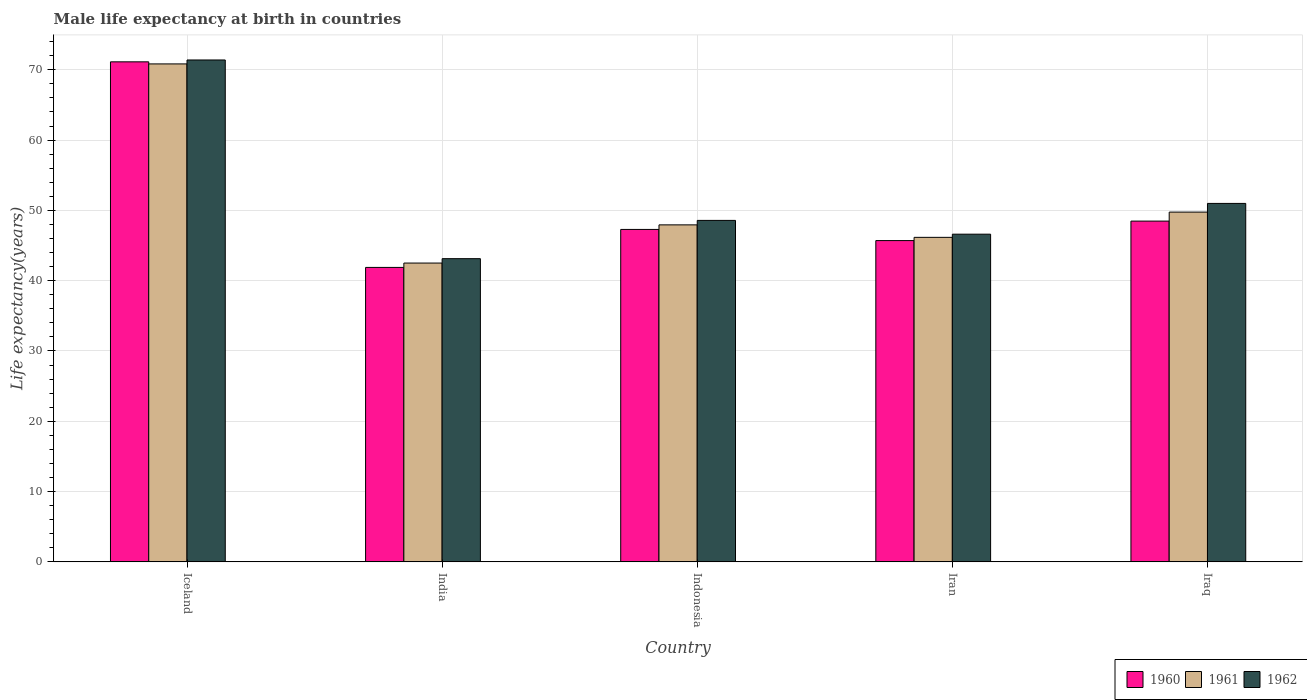How many different coloured bars are there?
Your answer should be very brief. 3. Are the number of bars on each tick of the X-axis equal?
Make the answer very short. Yes. How many bars are there on the 2nd tick from the left?
Offer a terse response. 3. What is the label of the 1st group of bars from the left?
Your answer should be very brief. Iceland. In how many cases, is the number of bars for a given country not equal to the number of legend labels?
Your response must be concise. 0. What is the male life expectancy at birth in 1962 in Iraq?
Make the answer very short. 50.99. Across all countries, what is the maximum male life expectancy at birth in 1962?
Make the answer very short. 71.4. Across all countries, what is the minimum male life expectancy at birth in 1962?
Your answer should be compact. 43.13. In which country was the male life expectancy at birth in 1962 minimum?
Keep it short and to the point. India. What is the total male life expectancy at birth in 1961 in the graph?
Keep it short and to the point. 257.22. What is the difference between the male life expectancy at birth in 1960 in India and that in Iran?
Provide a succinct answer. -3.82. What is the difference between the male life expectancy at birth in 1960 in Iceland and the male life expectancy at birth in 1962 in Iraq?
Provide a short and direct response. 20.14. What is the average male life expectancy at birth in 1960 per country?
Keep it short and to the point. 50.9. What is the difference between the male life expectancy at birth of/in 1962 and male life expectancy at birth of/in 1961 in Iceland?
Your answer should be compact. 0.56. What is the ratio of the male life expectancy at birth in 1961 in India to that in Iraq?
Your answer should be compact. 0.85. Is the difference between the male life expectancy at birth in 1962 in Iceland and India greater than the difference between the male life expectancy at birth in 1961 in Iceland and India?
Provide a short and direct response. No. What is the difference between the highest and the second highest male life expectancy at birth in 1962?
Make the answer very short. -2.41. What is the difference between the highest and the lowest male life expectancy at birth in 1961?
Your answer should be compact. 28.33. In how many countries, is the male life expectancy at birth in 1961 greater than the average male life expectancy at birth in 1961 taken over all countries?
Your response must be concise. 1. What does the 1st bar from the left in Iceland represents?
Keep it short and to the point. 1960. What does the 1st bar from the right in Iran represents?
Give a very brief answer. 1962. Is it the case that in every country, the sum of the male life expectancy at birth in 1962 and male life expectancy at birth in 1960 is greater than the male life expectancy at birth in 1961?
Your answer should be very brief. Yes. What is the difference between two consecutive major ticks on the Y-axis?
Your response must be concise. 10. Are the values on the major ticks of Y-axis written in scientific E-notation?
Your response must be concise. No. Does the graph contain grids?
Your answer should be compact. Yes. How many legend labels are there?
Offer a very short reply. 3. What is the title of the graph?
Keep it short and to the point. Male life expectancy at birth in countries. What is the label or title of the Y-axis?
Your answer should be compact. Life expectancy(years). What is the Life expectancy(years) in 1960 in Iceland?
Make the answer very short. 71.14. What is the Life expectancy(years) of 1961 in Iceland?
Give a very brief answer. 70.84. What is the Life expectancy(years) in 1962 in Iceland?
Provide a short and direct response. 71.4. What is the Life expectancy(years) in 1960 in India?
Ensure brevity in your answer.  41.89. What is the Life expectancy(years) in 1961 in India?
Provide a short and direct response. 42.51. What is the Life expectancy(years) in 1962 in India?
Make the answer very short. 43.13. What is the Life expectancy(years) of 1960 in Indonesia?
Your answer should be compact. 47.29. What is the Life expectancy(years) of 1961 in Indonesia?
Your response must be concise. 47.94. What is the Life expectancy(years) in 1962 in Indonesia?
Your answer should be compact. 48.58. What is the Life expectancy(years) in 1960 in Iran?
Keep it short and to the point. 45.71. What is the Life expectancy(years) in 1961 in Iran?
Your response must be concise. 46.17. What is the Life expectancy(years) of 1962 in Iran?
Your answer should be very brief. 46.62. What is the Life expectancy(years) in 1960 in Iraq?
Give a very brief answer. 48.48. What is the Life expectancy(years) of 1961 in Iraq?
Offer a terse response. 49.76. What is the Life expectancy(years) in 1962 in Iraq?
Offer a terse response. 50.99. Across all countries, what is the maximum Life expectancy(years) in 1960?
Ensure brevity in your answer.  71.14. Across all countries, what is the maximum Life expectancy(years) in 1961?
Make the answer very short. 70.84. Across all countries, what is the maximum Life expectancy(years) of 1962?
Offer a very short reply. 71.4. Across all countries, what is the minimum Life expectancy(years) in 1960?
Your answer should be compact. 41.89. Across all countries, what is the minimum Life expectancy(years) in 1961?
Your answer should be very brief. 42.51. Across all countries, what is the minimum Life expectancy(years) in 1962?
Ensure brevity in your answer.  43.13. What is the total Life expectancy(years) of 1960 in the graph?
Keep it short and to the point. 254.5. What is the total Life expectancy(years) in 1961 in the graph?
Provide a short and direct response. 257.22. What is the total Life expectancy(years) in 1962 in the graph?
Offer a very short reply. 260.72. What is the difference between the Life expectancy(years) of 1960 in Iceland and that in India?
Your answer should be compact. 29.25. What is the difference between the Life expectancy(years) in 1961 in Iceland and that in India?
Make the answer very short. 28.33. What is the difference between the Life expectancy(years) of 1962 in Iceland and that in India?
Provide a short and direct response. 28.27. What is the difference between the Life expectancy(years) of 1960 in Iceland and that in Indonesia?
Your response must be concise. 23.84. What is the difference between the Life expectancy(years) of 1961 in Iceland and that in Indonesia?
Provide a succinct answer. 22.9. What is the difference between the Life expectancy(years) of 1962 in Iceland and that in Indonesia?
Give a very brief answer. 22.82. What is the difference between the Life expectancy(years) of 1960 in Iceland and that in Iran?
Provide a short and direct response. 25.43. What is the difference between the Life expectancy(years) of 1961 in Iceland and that in Iran?
Your answer should be very brief. 24.67. What is the difference between the Life expectancy(years) in 1962 in Iceland and that in Iran?
Keep it short and to the point. 24.78. What is the difference between the Life expectancy(years) of 1960 in Iceland and that in Iraq?
Make the answer very short. 22.66. What is the difference between the Life expectancy(years) in 1961 in Iceland and that in Iraq?
Offer a terse response. 21.08. What is the difference between the Life expectancy(years) of 1962 in Iceland and that in Iraq?
Offer a terse response. 20.41. What is the difference between the Life expectancy(years) in 1960 in India and that in Indonesia?
Ensure brevity in your answer.  -5.4. What is the difference between the Life expectancy(years) in 1961 in India and that in Indonesia?
Keep it short and to the point. -5.43. What is the difference between the Life expectancy(years) of 1962 in India and that in Indonesia?
Provide a short and direct response. -5.44. What is the difference between the Life expectancy(years) of 1960 in India and that in Iran?
Provide a succinct answer. -3.82. What is the difference between the Life expectancy(years) in 1961 in India and that in Iran?
Your answer should be compact. -3.66. What is the difference between the Life expectancy(years) of 1962 in India and that in Iran?
Offer a very short reply. -3.48. What is the difference between the Life expectancy(years) in 1960 in India and that in Iraq?
Give a very brief answer. -6.59. What is the difference between the Life expectancy(years) of 1961 in India and that in Iraq?
Provide a short and direct response. -7.25. What is the difference between the Life expectancy(years) in 1962 in India and that in Iraq?
Make the answer very short. -7.86. What is the difference between the Life expectancy(years) of 1960 in Indonesia and that in Iran?
Offer a terse response. 1.59. What is the difference between the Life expectancy(years) in 1961 in Indonesia and that in Iran?
Your answer should be very brief. 1.77. What is the difference between the Life expectancy(years) of 1962 in Indonesia and that in Iran?
Keep it short and to the point. 1.96. What is the difference between the Life expectancy(years) in 1960 in Indonesia and that in Iraq?
Your answer should be very brief. -1.19. What is the difference between the Life expectancy(years) in 1961 in Indonesia and that in Iraq?
Your answer should be compact. -1.81. What is the difference between the Life expectancy(years) in 1962 in Indonesia and that in Iraq?
Your response must be concise. -2.42. What is the difference between the Life expectancy(years) in 1960 in Iran and that in Iraq?
Your response must be concise. -2.77. What is the difference between the Life expectancy(years) in 1961 in Iran and that in Iraq?
Your answer should be compact. -3.59. What is the difference between the Life expectancy(years) in 1962 in Iran and that in Iraq?
Your answer should be very brief. -4.38. What is the difference between the Life expectancy(years) of 1960 in Iceland and the Life expectancy(years) of 1961 in India?
Offer a terse response. 28.62. What is the difference between the Life expectancy(years) in 1960 in Iceland and the Life expectancy(years) in 1962 in India?
Ensure brevity in your answer.  28. What is the difference between the Life expectancy(years) in 1961 in Iceland and the Life expectancy(years) in 1962 in India?
Your response must be concise. 27.71. What is the difference between the Life expectancy(years) of 1960 in Iceland and the Life expectancy(years) of 1961 in Indonesia?
Your response must be concise. 23.19. What is the difference between the Life expectancy(years) in 1960 in Iceland and the Life expectancy(years) in 1962 in Indonesia?
Your answer should be compact. 22.56. What is the difference between the Life expectancy(years) of 1961 in Iceland and the Life expectancy(years) of 1962 in Indonesia?
Offer a terse response. 22.26. What is the difference between the Life expectancy(years) in 1960 in Iceland and the Life expectancy(years) in 1961 in Iran?
Give a very brief answer. 24.97. What is the difference between the Life expectancy(years) of 1960 in Iceland and the Life expectancy(years) of 1962 in Iran?
Give a very brief answer. 24.52. What is the difference between the Life expectancy(years) in 1961 in Iceland and the Life expectancy(years) in 1962 in Iran?
Ensure brevity in your answer.  24.22. What is the difference between the Life expectancy(years) of 1960 in Iceland and the Life expectancy(years) of 1961 in Iraq?
Offer a terse response. 21.38. What is the difference between the Life expectancy(years) in 1960 in Iceland and the Life expectancy(years) in 1962 in Iraq?
Provide a succinct answer. 20.14. What is the difference between the Life expectancy(years) in 1961 in Iceland and the Life expectancy(years) in 1962 in Iraq?
Offer a very short reply. 19.85. What is the difference between the Life expectancy(years) of 1960 in India and the Life expectancy(years) of 1961 in Indonesia?
Provide a short and direct response. -6.05. What is the difference between the Life expectancy(years) in 1960 in India and the Life expectancy(years) in 1962 in Indonesia?
Provide a short and direct response. -6.69. What is the difference between the Life expectancy(years) in 1961 in India and the Life expectancy(years) in 1962 in Indonesia?
Offer a terse response. -6.07. What is the difference between the Life expectancy(years) of 1960 in India and the Life expectancy(years) of 1961 in Iran?
Give a very brief answer. -4.28. What is the difference between the Life expectancy(years) of 1960 in India and the Life expectancy(years) of 1962 in Iran?
Ensure brevity in your answer.  -4.73. What is the difference between the Life expectancy(years) in 1961 in India and the Life expectancy(years) in 1962 in Iran?
Your answer should be very brief. -4.11. What is the difference between the Life expectancy(years) of 1960 in India and the Life expectancy(years) of 1961 in Iraq?
Provide a succinct answer. -7.87. What is the difference between the Life expectancy(years) in 1960 in India and the Life expectancy(years) in 1962 in Iraq?
Provide a succinct answer. -9.1. What is the difference between the Life expectancy(years) in 1961 in India and the Life expectancy(years) in 1962 in Iraq?
Provide a short and direct response. -8.48. What is the difference between the Life expectancy(years) of 1960 in Indonesia and the Life expectancy(years) of 1961 in Iran?
Offer a very short reply. 1.13. What is the difference between the Life expectancy(years) in 1960 in Indonesia and the Life expectancy(years) in 1962 in Iran?
Provide a short and direct response. 0.68. What is the difference between the Life expectancy(years) of 1961 in Indonesia and the Life expectancy(years) of 1962 in Iran?
Offer a very short reply. 1.32. What is the difference between the Life expectancy(years) in 1960 in Indonesia and the Life expectancy(years) in 1961 in Iraq?
Your answer should be very brief. -2.46. What is the difference between the Life expectancy(years) in 1960 in Indonesia and the Life expectancy(years) in 1962 in Iraq?
Provide a short and direct response. -3.7. What is the difference between the Life expectancy(years) in 1961 in Indonesia and the Life expectancy(years) in 1962 in Iraq?
Ensure brevity in your answer.  -3.05. What is the difference between the Life expectancy(years) of 1960 in Iran and the Life expectancy(years) of 1961 in Iraq?
Offer a terse response. -4.05. What is the difference between the Life expectancy(years) in 1960 in Iran and the Life expectancy(years) in 1962 in Iraq?
Give a very brief answer. -5.29. What is the difference between the Life expectancy(years) of 1961 in Iran and the Life expectancy(years) of 1962 in Iraq?
Offer a terse response. -4.83. What is the average Life expectancy(years) of 1960 per country?
Offer a terse response. 50.9. What is the average Life expectancy(years) in 1961 per country?
Your answer should be compact. 51.44. What is the average Life expectancy(years) of 1962 per country?
Your answer should be very brief. 52.14. What is the difference between the Life expectancy(years) of 1960 and Life expectancy(years) of 1961 in Iceland?
Make the answer very short. 0.29. What is the difference between the Life expectancy(years) of 1960 and Life expectancy(years) of 1962 in Iceland?
Your answer should be very brief. -0.27. What is the difference between the Life expectancy(years) of 1961 and Life expectancy(years) of 1962 in Iceland?
Your answer should be very brief. -0.56. What is the difference between the Life expectancy(years) in 1960 and Life expectancy(years) in 1961 in India?
Offer a very short reply. -0.62. What is the difference between the Life expectancy(years) in 1960 and Life expectancy(years) in 1962 in India?
Offer a very short reply. -1.24. What is the difference between the Life expectancy(years) in 1961 and Life expectancy(years) in 1962 in India?
Ensure brevity in your answer.  -0.62. What is the difference between the Life expectancy(years) in 1960 and Life expectancy(years) in 1961 in Indonesia?
Offer a terse response. -0.65. What is the difference between the Life expectancy(years) in 1960 and Life expectancy(years) in 1962 in Indonesia?
Your response must be concise. -1.28. What is the difference between the Life expectancy(years) of 1961 and Life expectancy(years) of 1962 in Indonesia?
Your answer should be very brief. -0.64. What is the difference between the Life expectancy(years) of 1960 and Life expectancy(years) of 1961 in Iran?
Your response must be concise. -0.46. What is the difference between the Life expectancy(years) of 1960 and Life expectancy(years) of 1962 in Iran?
Offer a very short reply. -0.91. What is the difference between the Life expectancy(years) of 1961 and Life expectancy(years) of 1962 in Iran?
Your answer should be very brief. -0.45. What is the difference between the Life expectancy(years) of 1960 and Life expectancy(years) of 1961 in Iraq?
Offer a terse response. -1.28. What is the difference between the Life expectancy(years) in 1960 and Life expectancy(years) in 1962 in Iraq?
Ensure brevity in your answer.  -2.52. What is the difference between the Life expectancy(years) of 1961 and Life expectancy(years) of 1962 in Iraq?
Your answer should be compact. -1.24. What is the ratio of the Life expectancy(years) in 1960 in Iceland to that in India?
Offer a terse response. 1.7. What is the ratio of the Life expectancy(years) in 1961 in Iceland to that in India?
Give a very brief answer. 1.67. What is the ratio of the Life expectancy(years) of 1962 in Iceland to that in India?
Your answer should be very brief. 1.66. What is the ratio of the Life expectancy(years) in 1960 in Iceland to that in Indonesia?
Offer a terse response. 1.5. What is the ratio of the Life expectancy(years) of 1961 in Iceland to that in Indonesia?
Give a very brief answer. 1.48. What is the ratio of the Life expectancy(years) of 1962 in Iceland to that in Indonesia?
Make the answer very short. 1.47. What is the ratio of the Life expectancy(years) in 1960 in Iceland to that in Iran?
Provide a short and direct response. 1.56. What is the ratio of the Life expectancy(years) in 1961 in Iceland to that in Iran?
Ensure brevity in your answer.  1.53. What is the ratio of the Life expectancy(years) in 1962 in Iceland to that in Iran?
Your answer should be compact. 1.53. What is the ratio of the Life expectancy(years) of 1960 in Iceland to that in Iraq?
Give a very brief answer. 1.47. What is the ratio of the Life expectancy(years) of 1961 in Iceland to that in Iraq?
Provide a succinct answer. 1.42. What is the ratio of the Life expectancy(years) of 1962 in Iceland to that in Iraq?
Ensure brevity in your answer.  1.4. What is the ratio of the Life expectancy(years) in 1960 in India to that in Indonesia?
Make the answer very short. 0.89. What is the ratio of the Life expectancy(years) in 1961 in India to that in Indonesia?
Ensure brevity in your answer.  0.89. What is the ratio of the Life expectancy(years) of 1962 in India to that in Indonesia?
Make the answer very short. 0.89. What is the ratio of the Life expectancy(years) of 1960 in India to that in Iran?
Offer a terse response. 0.92. What is the ratio of the Life expectancy(years) of 1961 in India to that in Iran?
Give a very brief answer. 0.92. What is the ratio of the Life expectancy(years) in 1962 in India to that in Iran?
Provide a short and direct response. 0.93. What is the ratio of the Life expectancy(years) in 1960 in India to that in Iraq?
Provide a short and direct response. 0.86. What is the ratio of the Life expectancy(years) of 1961 in India to that in Iraq?
Provide a short and direct response. 0.85. What is the ratio of the Life expectancy(years) in 1962 in India to that in Iraq?
Provide a short and direct response. 0.85. What is the ratio of the Life expectancy(years) of 1960 in Indonesia to that in Iran?
Your response must be concise. 1.03. What is the ratio of the Life expectancy(years) in 1961 in Indonesia to that in Iran?
Your response must be concise. 1.04. What is the ratio of the Life expectancy(years) of 1962 in Indonesia to that in Iran?
Provide a succinct answer. 1.04. What is the ratio of the Life expectancy(years) in 1960 in Indonesia to that in Iraq?
Ensure brevity in your answer.  0.98. What is the ratio of the Life expectancy(years) of 1961 in Indonesia to that in Iraq?
Ensure brevity in your answer.  0.96. What is the ratio of the Life expectancy(years) of 1962 in Indonesia to that in Iraq?
Give a very brief answer. 0.95. What is the ratio of the Life expectancy(years) of 1960 in Iran to that in Iraq?
Offer a terse response. 0.94. What is the ratio of the Life expectancy(years) of 1961 in Iran to that in Iraq?
Provide a short and direct response. 0.93. What is the ratio of the Life expectancy(years) in 1962 in Iran to that in Iraq?
Keep it short and to the point. 0.91. What is the difference between the highest and the second highest Life expectancy(years) in 1960?
Offer a very short reply. 22.66. What is the difference between the highest and the second highest Life expectancy(years) of 1961?
Offer a very short reply. 21.08. What is the difference between the highest and the second highest Life expectancy(years) in 1962?
Your answer should be compact. 20.41. What is the difference between the highest and the lowest Life expectancy(years) in 1960?
Offer a terse response. 29.25. What is the difference between the highest and the lowest Life expectancy(years) in 1961?
Keep it short and to the point. 28.33. What is the difference between the highest and the lowest Life expectancy(years) of 1962?
Give a very brief answer. 28.27. 